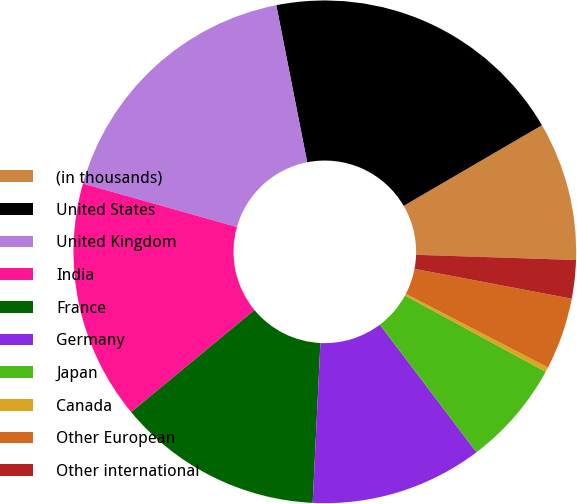<chart> <loc_0><loc_0><loc_500><loc_500><pie_chart><fcel>(in thousands)<fcel>United States<fcel>United Kingdom<fcel>India<fcel>France<fcel>Germany<fcel>Japan<fcel>Canada<fcel>Other European<fcel>Other international<nl><fcel>8.92%<fcel>19.69%<fcel>17.53%<fcel>15.38%<fcel>13.23%<fcel>11.08%<fcel>6.77%<fcel>0.31%<fcel>4.62%<fcel>2.47%<nl></chart> 